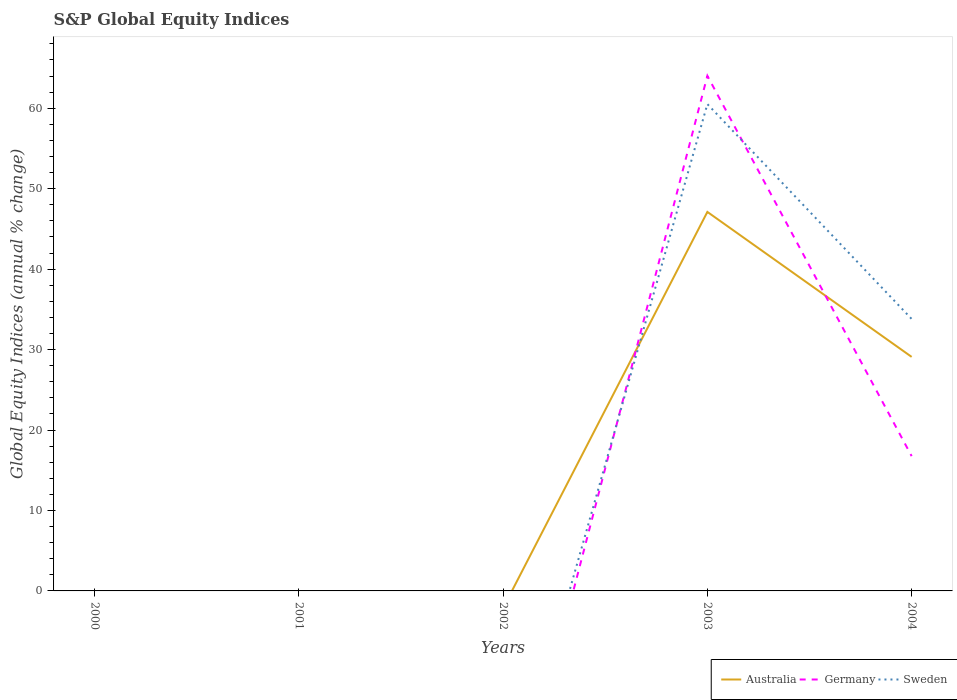Across all years, what is the maximum global equity indices in Australia?
Provide a short and direct response. 0. What is the difference between the highest and the second highest global equity indices in Sweden?
Keep it short and to the point. 60.51. What is the difference between the highest and the lowest global equity indices in Australia?
Keep it short and to the point. 2. Is the global equity indices in Sweden strictly greater than the global equity indices in Germany over the years?
Your answer should be compact. No. What is the difference between two consecutive major ticks on the Y-axis?
Offer a very short reply. 10. Are the values on the major ticks of Y-axis written in scientific E-notation?
Ensure brevity in your answer.  No. Does the graph contain any zero values?
Your answer should be very brief. Yes. How many legend labels are there?
Offer a very short reply. 3. How are the legend labels stacked?
Give a very brief answer. Horizontal. What is the title of the graph?
Your response must be concise. S&P Global Equity Indices. What is the label or title of the Y-axis?
Make the answer very short. Global Equity Indices (annual % change). What is the Global Equity Indices (annual % change) in Australia in 2000?
Ensure brevity in your answer.  0. What is the Global Equity Indices (annual % change) of Germany in 2000?
Your answer should be compact. 0. What is the Global Equity Indices (annual % change) of Australia in 2001?
Offer a very short reply. 0. What is the Global Equity Indices (annual % change) of Australia in 2002?
Ensure brevity in your answer.  0. What is the Global Equity Indices (annual % change) of Germany in 2002?
Give a very brief answer. 0. What is the Global Equity Indices (annual % change) in Sweden in 2002?
Give a very brief answer. 0. What is the Global Equity Indices (annual % change) of Australia in 2003?
Offer a terse response. 47.11. What is the Global Equity Indices (annual % change) of Germany in 2003?
Provide a succinct answer. 64.03. What is the Global Equity Indices (annual % change) of Sweden in 2003?
Offer a terse response. 60.51. What is the Global Equity Indices (annual % change) of Australia in 2004?
Provide a succinct answer. 29.09. What is the Global Equity Indices (annual % change) in Germany in 2004?
Your answer should be compact. 16.75. What is the Global Equity Indices (annual % change) in Sweden in 2004?
Offer a terse response. 33.81. Across all years, what is the maximum Global Equity Indices (annual % change) in Australia?
Your answer should be compact. 47.11. Across all years, what is the maximum Global Equity Indices (annual % change) in Germany?
Your response must be concise. 64.03. Across all years, what is the maximum Global Equity Indices (annual % change) of Sweden?
Make the answer very short. 60.51. Across all years, what is the minimum Global Equity Indices (annual % change) of Sweden?
Make the answer very short. 0. What is the total Global Equity Indices (annual % change) of Australia in the graph?
Provide a succinct answer. 76.21. What is the total Global Equity Indices (annual % change) of Germany in the graph?
Offer a terse response. 80.79. What is the total Global Equity Indices (annual % change) in Sweden in the graph?
Your answer should be very brief. 94.32. What is the difference between the Global Equity Indices (annual % change) in Australia in 2003 and that in 2004?
Your answer should be very brief. 18.02. What is the difference between the Global Equity Indices (annual % change) of Germany in 2003 and that in 2004?
Offer a terse response. 47.28. What is the difference between the Global Equity Indices (annual % change) of Sweden in 2003 and that in 2004?
Make the answer very short. 26.71. What is the difference between the Global Equity Indices (annual % change) in Australia in 2003 and the Global Equity Indices (annual % change) in Germany in 2004?
Make the answer very short. 30.36. What is the difference between the Global Equity Indices (annual % change) in Australia in 2003 and the Global Equity Indices (annual % change) in Sweden in 2004?
Ensure brevity in your answer.  13.31. What is the difference between the Global Equity Indices (annual % change) in Germany in 2003 and the Global Equity Indices (annual % change) in Sweden in 2004?
Make the answer very short. 30.22. What is the average Global Equity Indices (annual % change) in Australia per year?
Give a very brief answer. 15.24. What is the average Global Equity Indices (annual % change) of Germany per year?
Your answer should be very brief. 16.16. What is the average Global Equity Indices (annual % change) of Sweden per year?
Ensure brevity in your answer.  18.86. In the year 2003, what is the difference between the Global Equity Indices (annual % change) of Australia and Global Equity Indices (annual % change) of Germany?
Your answer should be compact. -16.92. In the year 2003, what is the difference between the Global Equity Indices (annual % change) of Australia and Global Equity Indices (annual % change) of Sweden?
Your answer should be compact. -13.4. In the year 2003, what is the difference between the Global Equity Indices (annual % change) in Germany and Global Equity Indices (annual % change) in Sweden?
Offer a very short reply. 3.52. In the year 2004, what is the difference between the Global Equity Indices (annual % change) of Australia and Global Equity Indices (annual % change) of Germany?
Give a very brief answer. 12.34. In the year 2004, what is the difference between the Global Equity Indices (annual % change) of Australia and Global Equity Indices (annual % change) of Sweden?
Provide a succinct answer. -4.71. In the year 2004, what is the difference between the Global Equity Indices (annual % change) of Germany and Global Equity Indices (annual % change) of Sweden?
Your response must be concise. -17.05. What is the ratio of the Global Equity Indices (annual % change) of Australia in 2003 to that in 2004?
Offer a very short reply. 1.62. What is the ratio of the Global Equity Indices (annual % change) in Germany in 2003 to that in 2004?
Keep it short and to the point. 3.82. What is the ratio of the Global Equity Indices (annual % change) of Sweden in 2003 to that in 2004?
Offer a very short reply. 1.79. What is the difference between the highest and the lowest Global Equity Indices (annual % change) of Australia?
Make the answer very short. 47.11. What is the difference between the highest and the lowest Global Equity Indices (annual % change) of Germany?
Provide a succinct answer. 64.03. What is the difference between the highest and the lowest Global Equity Indices (annual % change) of Sweden?
Offer a very short reply. 60.51. 